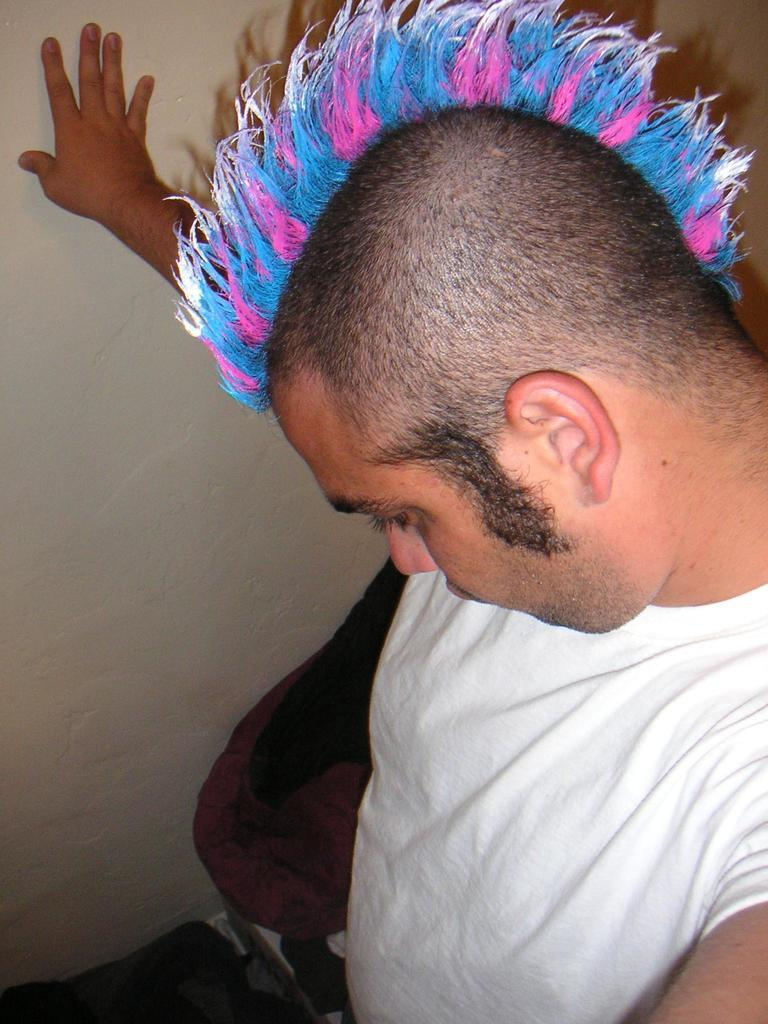What is the position of the man in the image? The man is on the right side of the image. What is the man wearing in the image? The man is wearing a white t-shirt. What direction is the man looking in the image? The man is looking downwards. What can be seen on the ground in the image? There are objects placed on the ground. What is on the left side of the image? There is a wall on the left side of the image. What news is the man reading from the vest in the image? There is no vest or news present in the image. The man is wearing a white t-shirt, and there is no mention of news or reading in the provided facts. 